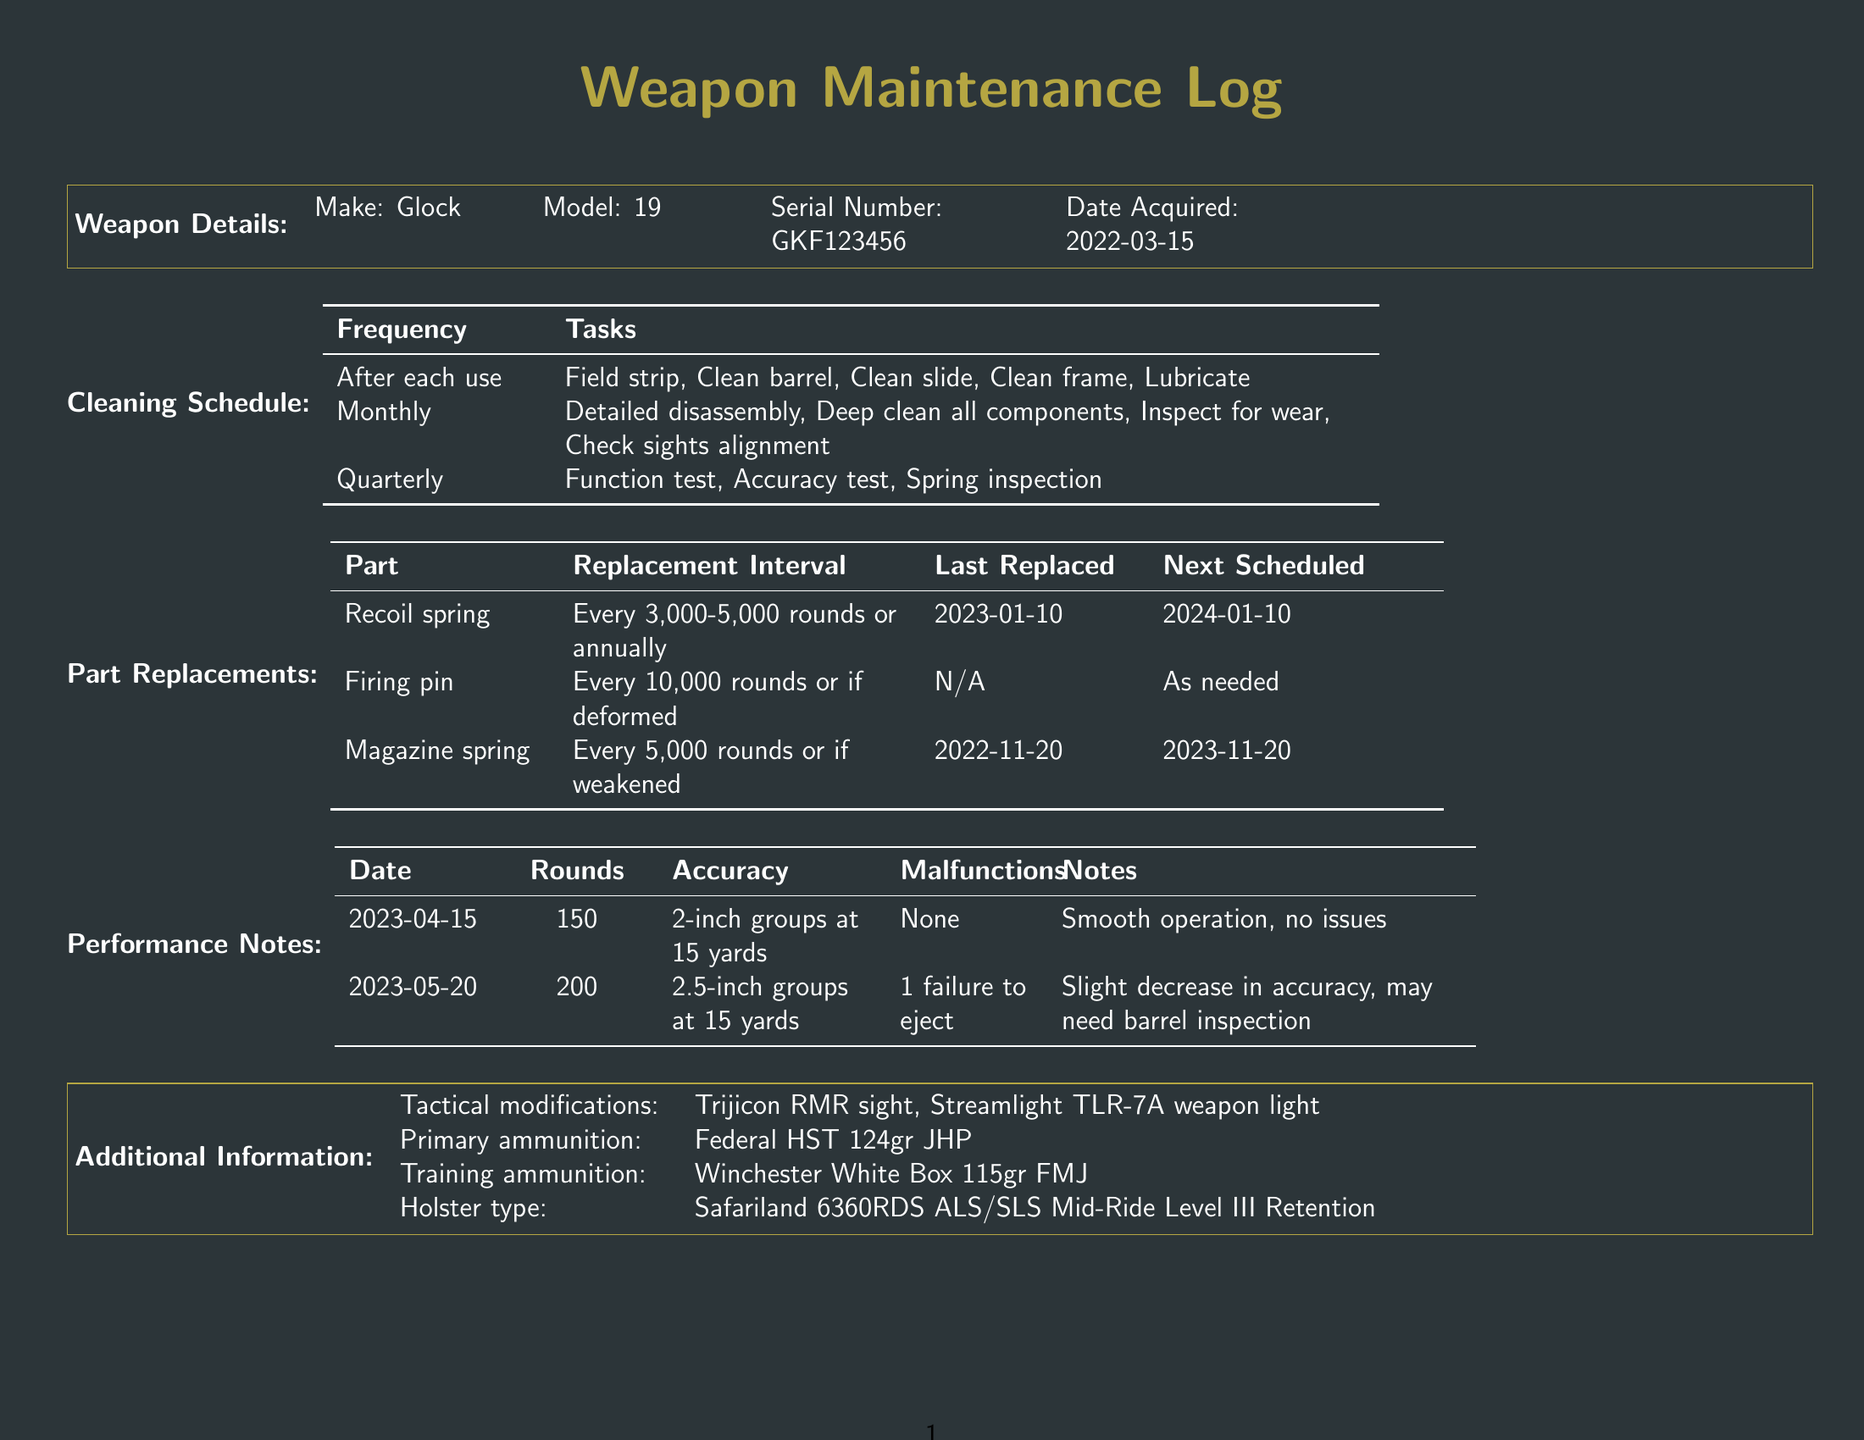what is the make of the weapon? The make of the weapon is stated in the weapon details section.
Answer: Glock what is the model of the weapon? The model of the weapon is specified alongside its make in the details section.
Answer: 19 when was the recoil spring last replaced? The last replaced date for the recoil spring is mentioned in the part replacements section.
Answer: 2023-01-10 what is the accuracy of the rounds fired on April 15, 2023? The performance notes provide the accuracy for the specified date.
Answer: 2-inch groups at 15 yards how often should the magazine spring be replaced? The replacement interval for the magazine spring is included in the part replacements section.
Answer: Every 5,000 rounds or if weakened what modifications have been made to the weapon? The tactical modifications are listed in the additional information section.
Answer: Trijicon RMR sight, Streamlight TLR-7A weapon light how many rounds were fired on May 20, 2023? The performance notes show the number of rounds fired on this date.
Answer: 200 what is the next scheduled replacement for the magazine spring? The next scheduled replacement date is mentioned in the part replacements section.
Answer: 2023-11-20 what malfunction occurred on May 20, 2023? The performance notes detail any malfunctions for this date.
Answer: 1 failure to eject 